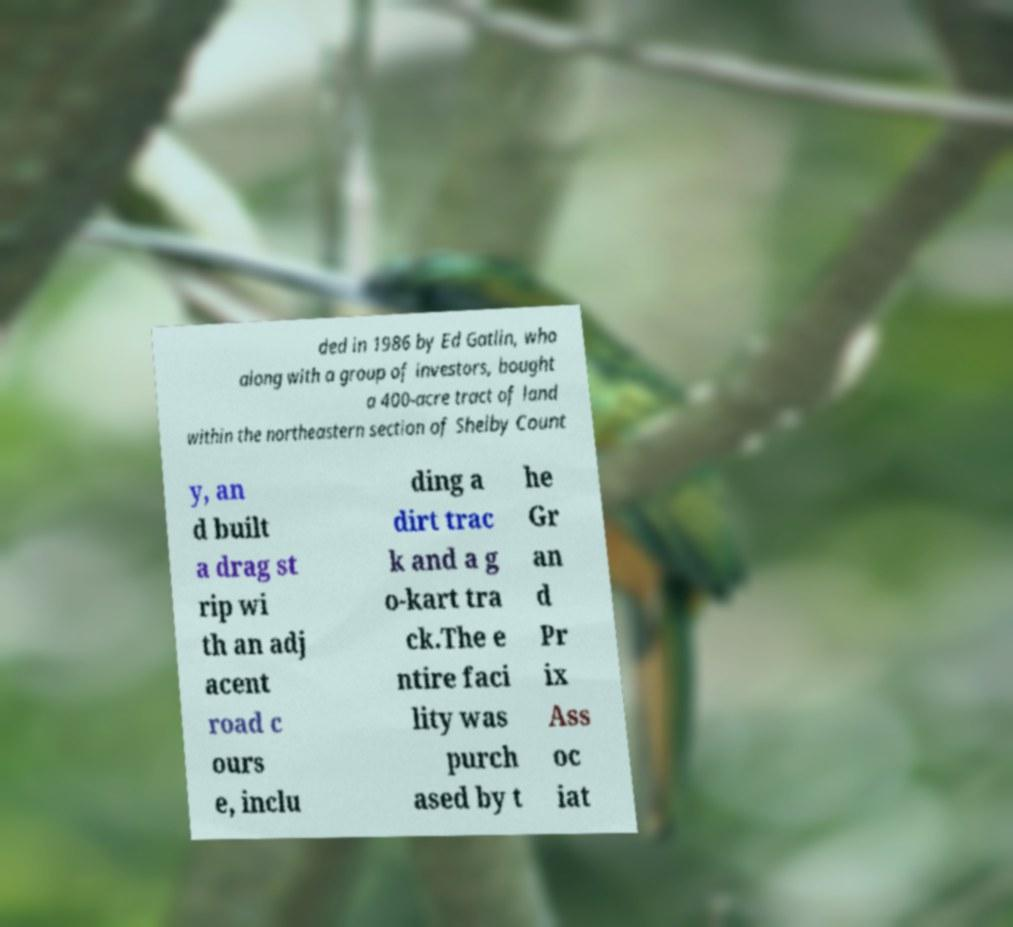Can you accurately transcribe the text from the provided image for me? ded in 1986 by Ed Gatlin, who along with a group of investors, bought a 400-acre tract of land within the northeastern section of Shelby Count y, an d built a drag st rip wi th an adj acent road c ours e, inclu ding a dirt trac k and a g o-kart tra ck.The e ntire faci lity was purch ased by t he Gr an d Pr ix Ass oc iat 